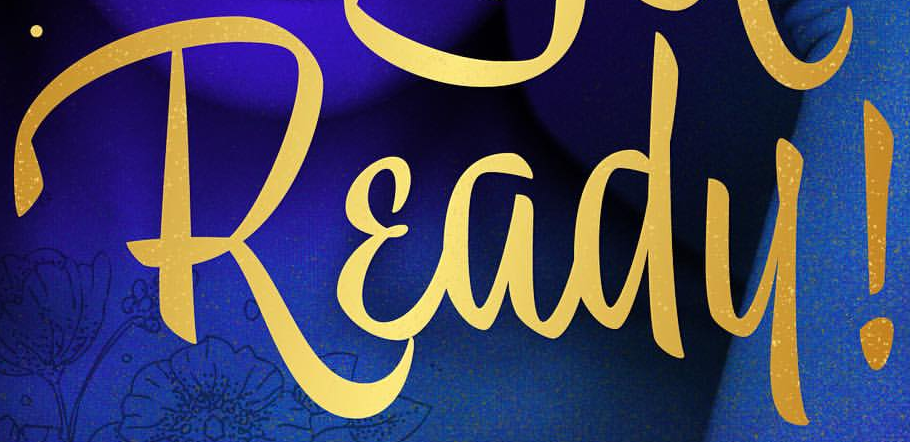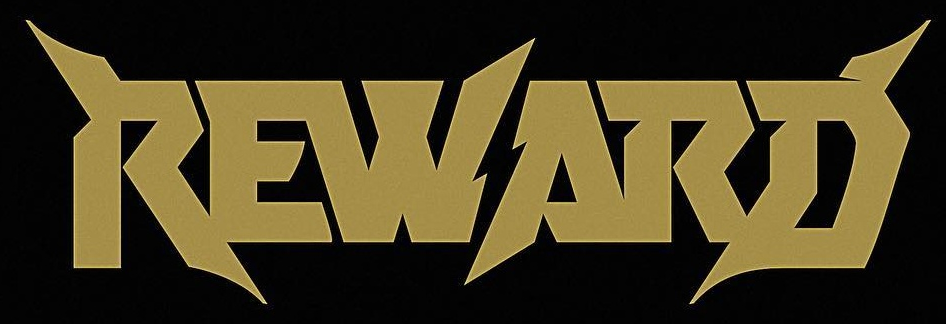Read the text from these images in sequence, separated by a semicolon. Ready!; REWARD 